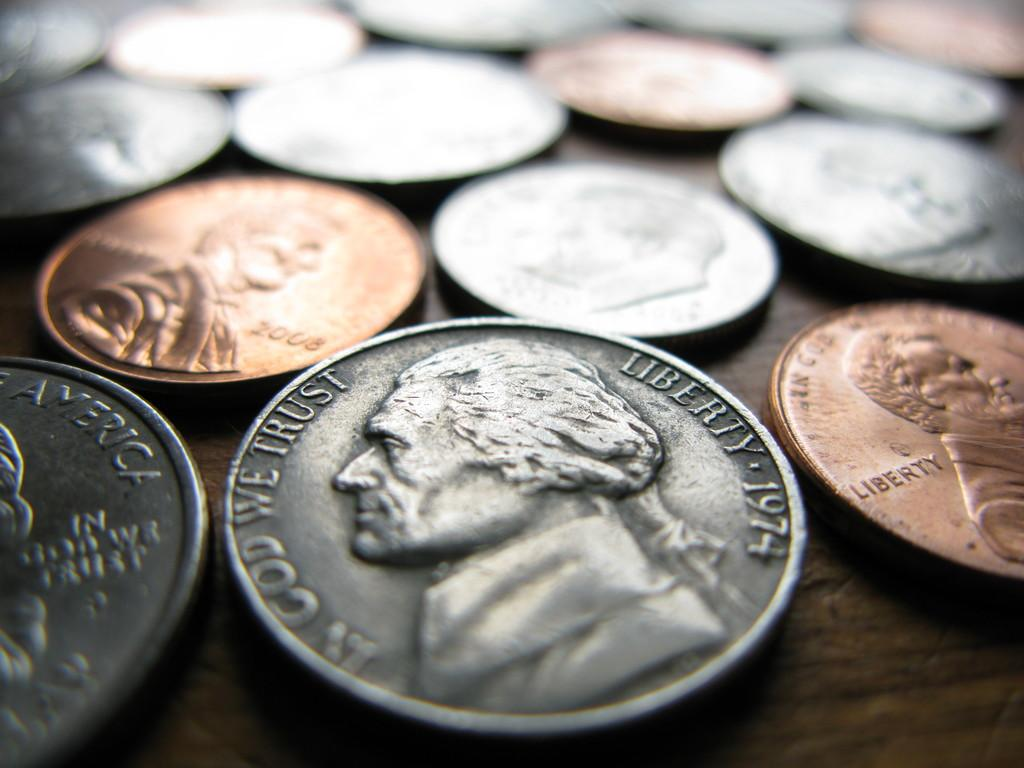<image>
Offer a succinct explanation of the picture presented. A 1974 nickel is among the many coins on the table. 